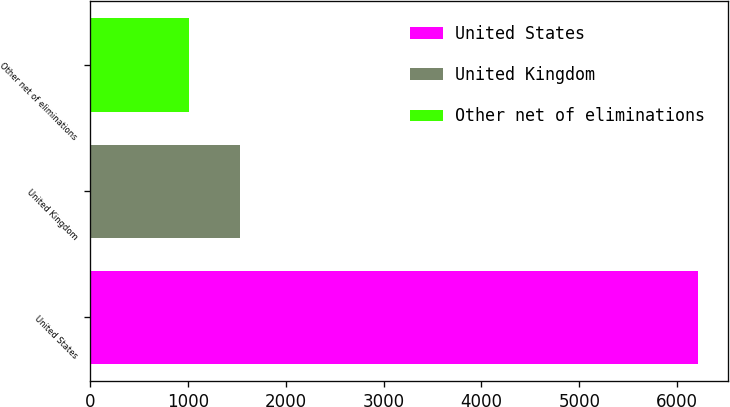Convert chart. <chart><loc_0><loc_0><loc_500><loc_500><bar_chart><fcel>United States<fcel>United Kingdom<fcel>Other net of eliminations<nl><fcel>6213<fcel>1526.7<fcel>1006<nl></chart> 